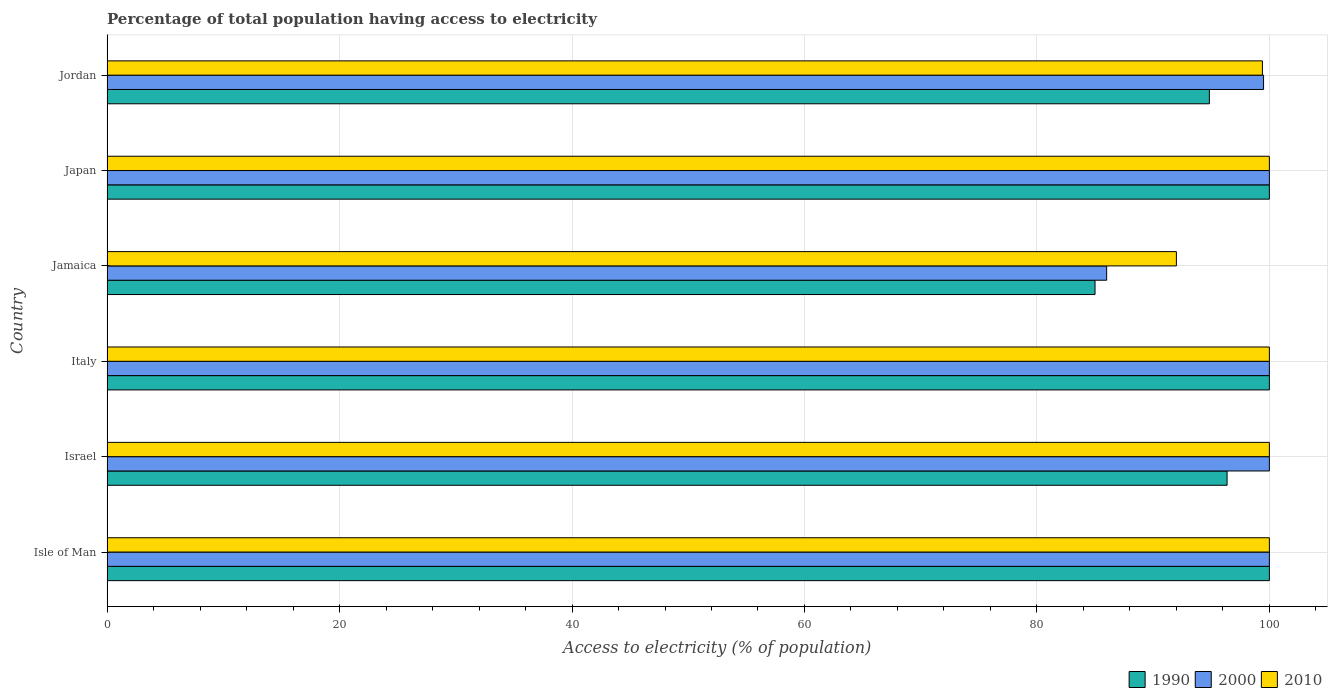How many different coloured bars are there?
Your answer should be compact. 3. Are the number of bars per tick equal to the number of legend labels?
Your answer should be compact. Yes. What is the label of the 6th group of bars from the top?
Your answer should be very brief. Isle of Man. What is the percentage of population that have access to electricity in 1990 in Israel?
Provide a succinct answer. 96.36. Across all countries, what is the maximum percentage of population that have access to electricity in 1990?
Keep it short and to the point. 100. In which country was the percentage of population that have access to electricity in 1990 maximum?
Ensure brevity in your answer.  Isle of Man. In which country was the percentage of population that have access to electricity in 2000 minimum?
Your answer should be very brief. Jamaica. What is the total percentage of population that have access to electricity in 1990 in the graph?
Offer a very short reply. 576.2. What is the difference between the percentage of population that have access to electricity in 2000 in Israel and that in Jordan?
Your response must be concise. 0.5. What is the average percentage of population that have access to electricity in 2010 per country?
Provide a succinct answer. 98.57. What is the ratio of the percentage of population that have access to electricity in 2000 in Israel to that in Italy?
Your response must be concise. 1. Is the percentage of population that have access to electricity in 1990 in Italy less than that in Japan?
Give a very brief answer. No. Is the difference between the percentage of population that have access to electricity in 2010 in Israel and Jamaica greater than the difference between the percentage of population that have access to electricity in 2000 in Israel and Jamaica?
Your answer should be compact. No. What is the difference between the highest and the second highest percentage of population that have access to electricity in 2000?
Provide a short and direct response. 0. How many countries are there in the graph?
Offer a terse response. 6. What is the title of the graph?
Your answer should be very brief. Percentage of total population having access to electricity. What is the label or title of the X-axis?
Your response must be concise. Access to electricity (% of population). What is the Access to electricity (% of population) in 1990 in Israel?
Provide a succinct answer. 96.36. What is the Access to electricity (% of population) of 2000 in Israel?
Offer a terse response. 100. What is the Access to electricity (% of population) of 2000 in Italy?
Make the answer very short. 100. What is the Access to electricity (% of population) of 2000 in Jamaica?
Ensure brevity in your answer.  86. What is the Access to electricity (% of population) in 2010 in Jamaica?
Offer a very short reply. 92. What is the Access to electricity (% of population) in 1990 in Japan?
Give a very brief answer. 100. What is the Access to electricity (% of population) in 2000 in Japan?
Give a very brief answer. 100. What is the Access to electricity (% of population) in 2010 in Japan?
Make the answer very short. 100. What is the Access to electricity (% of population) of 1990 in Jordan?
Keep it short and to the point. 94.84. What is the Access to electricity (% of population) of 2000 in Jordan?
Your response must be concise. 99.5. What is the Access to electricity (% of population) in 2010 in Jordan?
Your answer should be compact. 99.4. Across all countries, what is the maximum Access to electricity (% of population) of 1990?
Your response must be concise. 100. Across all countries, what is the minimum Access to electricity (% of population) of 1990?
Make the answer very short. 85. Across all countries, what is the minimum Access to electricity (% of population) of 2000?
Offer a terse response. 86. Across all countries, what is the minimum Access to electricity (% of population) of 2010?
Ensure brevity in your answer.  92. What is the total Access to electricity (% of population) of 1990 in the graph?
Provide a short and direct response. 576.2. What is the total Access to electricity (% of population) in 2000 in the graph?
Your answer should be very brief. 585.5. What is the total Access to electricity (% of population) of 2010 in the graph?
Keep it short and to the point. 591.4. What is the difference between the Access to electricity (% of population) of 1990 in Isle of Man and that in Israel?
Your response must be concise. 3.64. What is the difference between the Access to electricity (% of population) in 2010 in Isle of Man and that in Israel?
Offer a terse response. 0. What is the difference between the Access to electricity (% of population) of 1990 in Isle of Man and that in Italy?
Ensure brevity in your answer.  0. What is the difference between the Access to electricity (% of population) of 2000 in Isle of Man and that in Italy?
Keep it short and to the point. 0. What is the difference between the Access to electricity (% of population) of 1990 in Isle of Man and that in Japan?
Offer a very short reply. 0. What is the difference between the Access to electricity (% of population) of 2000 in Isle of Man and that in Japan?
Provide a succinct answer. 0. What is the difference between the Access to electricity (% of population) in 1990 in Isle of Man and that in Jordan?
Your answer should be compact. 5.16. What is the difference between the Access to electricity (% of population) in 2000 in Isle of Man and that in Jordan?
Ensure brevity in your answer.  0.5. What is the difference between the Access to electricity (% of population) in 1990 in Israel and that in Italy?
Provide a short and direct response. -3.64. What is the difference between the Access to electricity (% of population) of 2000 in Israel and that in Italy?
Give a very brief answer. 0. What is the difference between the Access to electricity (% of population) in 2010 in Israel and that in Italy?
Keep it short and to the point. 0. What is the difference between the Access to electricity (% of population) in 1990 in Israel and that in Jamaica?
Provide a short and direct response. 11.36. What is the difference between the Access to electricity (% of population) in 2000 in Israel and that in Jamaica?
Offer a very short reply. 14. What is the difference between the Access to electricity (% of population) in 1990 in Israel and that in Japan?
Keep it short and to the point. -3.64. What is the difference between the Access to electricity (% of population) of 2000 in Israel and that in Japan?
Your response must be concise. 0. What is the difference between the Access to electricity (% of population) of 2010 in Israel and that in Japan?
Offer a terse response. 0. What is the difference between the Access to electricity (% of population) in 1990 in Israel and that in Jordan?
Give a very brief answer. 1.52. What is the difference between the Access to electricity (% of population) in 2000 in Israel and that in Jordan?
Your answer should be compact. 0.5. What is the difference between the Access to electricity (% of population) in 1990 in Italy and that in Jamaica?
Offer a very short reply. 15. What is the difference between the Access to electricity (% of population) of 2010 in Italy and that in Japan?
Your response must be concise. 0. What is the difference between the Access to electricity (% of population) of 1990 in Italy and that in Jordan?
Offer a terse response. 5.16. What is the difference between the Access to electricity (% of population) in 2000 in Italy and that in Jordan?
Your answer should be compact. 0.5. What is the difference between the Access to electricity (% of population) of 2010 in Italy and that in Jordan?
Ensure brevity in your answer.  0.6. What is the difference between the Access to electricity (% of population) in 1990 in Jamaica and that in Jordan?
Ensure brevity in your answer.  -9.84. What is the difference between the Access to electricity (% of population) of 2000 in Jamaica and that in Jordan?
Offer a very short reply. -13.5. What is the difference between the Access to electricity (% of population) of 1990 in Japan and that in Jordan?
Offer a terse response. 5.16. What is the difference between the Access to electricity (% of population) of 1990 in Isle of Man and the Access to electricity (% of population) of 2010 in Israel?
Offer a very short reply. 0. What is the difference between the Access to electricity (% of population) in 2000 in Isle of Man and the Access to electricity (% of population) in 2010 in Israel?
Give a very brief answer. 0. What is the difference between the Access to electricity (% of population) of 1990 in Isle of Man and the Access to electricity (% of population) of 2000 in Italy?
Offer a terse response. 0. What is the difference between the Access to electricity (% of population) of 1990 in Isle of Man and the Access to electricity (% of population) of 2010 in Italy?
Make the answer very short. 0. What is the difference between the Access to electricity (% of population) of 1990 in Isle of Man and the Access to electricity (% of population) of 2010 in Jamaica?
Ensure brevity in your answer.  8. What is the difference between the Access to electricity (% of population) in 1990 in Isle of Man and the Access to electricity (% of population) in 2010 in Japan?
Your response must be concise. 0. What is the difference between the Access to electricity (% of population) in 2000 in Isle of Man and the Access to electricity (% of population) in 2010 in Japan?
Your answer should be very brief. 0. What is the difference between the Access to electricity (% of population) of 1990 in Isle of Man and the Access to electricity (% of population) of 2000 in Jordan?
Provide a short and direct response. 0.5. What is the difference between the Access to electricity (% of population) in 1990 in Isle of Man and the Access to electricity (% of population) in 2010 in Jordan?
Provide a short and direct response. 0.6. What is the difference between the Access to electricity (% of population) in 1990 in Israel and the Access to electricity (% of population) in 2000 in Italy?
Make the answer very short. -3.64. What is the difference between the Access to electricity (% of population) in 1990 in Israel and the Access to electricity (% of population) in 2010 in Italy?
Your answer should be compact. -3.64. What is the difference between the Access to electricity (% of population) of 2000 in Israel and the Access to electricity (% of population) of 2010 in Italy?
Ensure brevity in your answer.  0. What is the difference between the Access to electricity (% of population) of 1990 in Israel and the Access to electricity (% of population) of 2000 in Jamaica?
Ensure brevity in your answer.  10.36. What is the difference between the Access to electricity (% of population) of 1990 in Israel and the Access to electricity (% of population) of 2010 in Jamaica?
Provide a succinct answer. 4.36. What is the difference between the Access to electricity (% of population) of 2000 in Israel and the Access to electricity (% of population) of 2010 in Jamaica?
Your answer should be compact. 8. What is the difference between the Access to electricity (% of population) in 1990 in Israel and the Access to electricity (% of population) in 2000 in Japan?
Your response must be concise. -3.64. What is the difference between the Access to electricity (% of population) of 1990 in Israel and the Access to electricity (% of population) of 2010 in Japan?
Give a very brief answer. -3.64. What is the difference between the Access to electricity (% of population) in 2000 in Israel and the Access to electricity (% of population) in 2010 in Japan?
Give a very brief answer. 0. What is the difference between the Access to electricity (% of population) in 1990 in Israel and the Access to electricity (% of population) in 2000 in Jordan?
Provide a short and direct response. -3.14. What is the difference between the Access to electricity (% of population) in 1990 in Israel and the Access to electricity (% of population) in 2010 in Jordan?
Your answer should be compact. -3.04. What is the difference between the Access to electricity (% of population) in 1990 in Italy and the Access to electricity (% of population) in 2000 in Jamaica?
Your response must be concise. 14. What is the difference between the Access to electricity (% of population) of 1990 in Italy and the Access to electricity (% of population) of 2010 in Jamaica?
Provide a short and direct response. 8. What is the difference between the Access to electricity (% of population) in 2000 in Italy and the Access to electricity (% of population) in 2010 in Jamaica?
Give a very brief answer. 8. What is the difference between the Access to electricity (% of population) in 1990 in Italy and the Access to electricity (% of population) in 2000 in Japan?
Ensure brevity in your answer.  0. What is the difference between the Access to electricity (% of population) in 2000 in Italy and the Access to electricity (% of population) in 2010 in Japan?
Provide a succinct answer. 0. What is the difference between the Access to electricity (% of population) of 1990 in Jamaica and the Access to electricity (% of population) of 2010 in Japan?
Ensure brevity in your answer.  -15. What is the difference between the Access to electricity (% of population) of 1990 in Jamaica and the Access to electricity (% of population) of 2000 in Jordan?
Provide a short and direct response. -14.5. What is the difference between the Access to electricity (% of population) in 1990 in Jamaica and the Access to electricity (% of population) in 2010 in Jordan?
Provide a succinct answer. -14.4. What is the difference between the Access to electricity (% of population) in 1990 in Japan and the Access to electricity (% of population) in 2000 in Jordan?
Offer a terse response. 0.5. What is the difference between the Access to electricity (% of population) in 2000 in Japan and the Access to electricity (% of population) in 2010 in Jordan?
Keep it short and to the point. 0.6. What is the average Access to electricity (% of population) of 1990 per country?
Offer a terse response. 96.03. What is the average Access to electricity (% of population) in 2000 per country?
Offer a terse response. 97.58. What is the average Access to electricity (% of population) of 2010 per country?
Your answer should be compact. 98.57. What is the difference between the Access to electricity (% of population) in 1990 and Access to electricity (% of population) in 2010 in Isle of Man?
Give a very brief answer. 0. What is the difference between the Access to electricity (% of population) of 2000 and Access to electricity (% of population) of 2010 in Isle of Man?
Offer a very short reply. 0. What is the difference between the Access to electricity (% of population) of 1990 and Access to electricity (% of population) of 2000 in Israel?
Provide a short and direct response. -3.64. What is the difference between the Access to electricity (% of population) in 1990 and Access to electricity (% of population) in 2010 in Israel?
Offer a terse response. -3.64. What is the difference between the Access to electricity (% of population) of 1990 and Access to electricity (% of population) of 2000 in Jamaica?
Your response must be concise. -1. What is the difference between the Access to electricity (% of population) of 2000 and Access to electricity (% of population) of 2010 in Jamaica?
Make the answer very short. -6. What is the difference between the Access to electricity (% of population) of 1990 and Access to electricity (% of population) of 2000 in Japan?
Ensure brevity in your answer.  0. What is the difference between the Access to electricity (% of population) in 1990 and Access to electricity (% of population) in 2010 in Japan?
Offer a terse response. 0. What is the difference between the Access to electricity (% of population) in 1990 and Access to electricity (% of population) in 2000 in Jordan?
Provide a succinct answer. -4.66. What is the difference between the Access to electricity (% of population) in 1990 and Access to electricity (% of population) in 2010 in Jordan?
Provide a succinct answer. -4.56. What is the ratio of the Access to electricity (% of population) in 1990 in Isle of Man to that in Israel?
Your answer should be compact. 1.04. What is the ratio of the Access to electricity (% of population) of 2010 in Isle of Man to that in Israel?
Your answer should be compact. 1. What is the ratio of the Access to electricity (% of population) in 1990 in Isle of Man to that in Jamaica?
Provide a short and direct response. 1.18. What is the ratio of the Access to electricity (% of population) in 2000 in Isle of Man to that in Jamaica?
Provide a short and direct response. 1.16. What is the ratio of the Access to electricity (% of population) in 2010 in Isle of Man to that in Jamaica?
Provide a short and direct response. 1.09. What is the ratio of the Access to electricity (% of population) in 1990 in Isle of Man to that in Jordan?
Offer a terse response. 1.05. What is the ratio of the Access to electricity (% of population) of 2000 in Isle of Man to that in Jordan?
Ensure brevity in your answer.  1. What is the ratio of the Access to electricity (% of population) of 2010 in Isle of Man to that in Jordan?
Give a very brief answer. 1.01. What is the ratio of the Access to electricity (% of population) of 1990 in Israel to that in Italy?
Your answer should be very brief. 0.96. What is the ratio of the Access to electricity (% of population) of 1990 in Israel to that in Jamaica?
Offer a terse response. 1.13. What is the ratio of the Access to electricity (% of population) in 2000 in Israel to that in Jamaica?
Your answer should be compact. 1.16. What is the ratio of the Access to electricity (% of population) of 2010 in Israel to that in Jamaica?
Your response must be concise. 1.09. What is the ratio of the Access to electricity (% of population) of 1990 in Israel to that in Japan?
Offer a very short reply. 0.96. What is the ratio of the Access to electricity (% of population) in 2010 in Israel to that in Japan?
Your answer should be very brief. 1. What is the ratio of the Access to electricity (% of population) of 1990 in Israel to that in Jordan?
Make the answer very short. 1.02. What is the ratio of the Access to electricity (% of population) in 1990 in Italy to that in Jamaica?
Provide a short and direct response. 1.18. What is the ratio of the Access to electricity (% of population) in 2000 in Italy to that in Jamaica?
Offer a very short reply. 1.16. What is the ratio of the Access to electricity (% of population) of 2010 in Italy to that in Jamaica?
Give a very brief answer. 1.09. What is the ratio of the Access to electricity (% of population) of 1990 in Italy to that in Japan?
Ensure brevity in your answer.  1. What is the ratio of the Access to electricity (% of population) of 2000 in Italy to that in Japan?
Your response must be concise. 1. What is the ratio of the Access to electricity (% of population) in 2010 in Italy to that in Japan?
Make the answer very short. 1. What is the ratio of the Access to electricity (% of population) of 1990 in Italy to that in Jordan?
Give a very brief answer. 1.05. What is the ratio of the Access to electricity (% of population) in 2000 in Italy to that in Jordan?
Provide a succinct answer. 1. What is the ratio of the Access to electricity (% of population) in 1990 in Jamaica to that in Japan?
Ensure brevity in your answer.  0.85. What is the ratio of the Access to electricity (% of population) in 2000 in Jamaica to that in Japan?
Give a very brief answer. 0.86. What is the ratio of the Access to electricity (% of population) of 1990 in Jamaica to that in Jordan?
Offer a very short reply. 0.9. What is the ratio of the Access to electricity (% of population) in 2000 in Jamaica to that in Jordan?
Provide a short and direct response. 0.86. What is the ratio of the Access to electricity (% of population) of 2010 in Jamaica to that in Jordan?
Keep it short and to the point. 0.93. What is the ratio of the Access to electricity (% of population) in 1990 in Japan to that in Jordan?
Keep it short and to the point. 1.05. What is the difference between the highest and the second highest Access to electricity (% of population) in 1990?
Ensure brevity in your answer.  0. What is the difference between the highest and the lowest Access to electricity (% of population) of 2000?
Provide a succinct answer. 14. What is the difference between the highest and the lowest Access to electricity (% of population) of 2010?
Your answer should be compact. 8. 